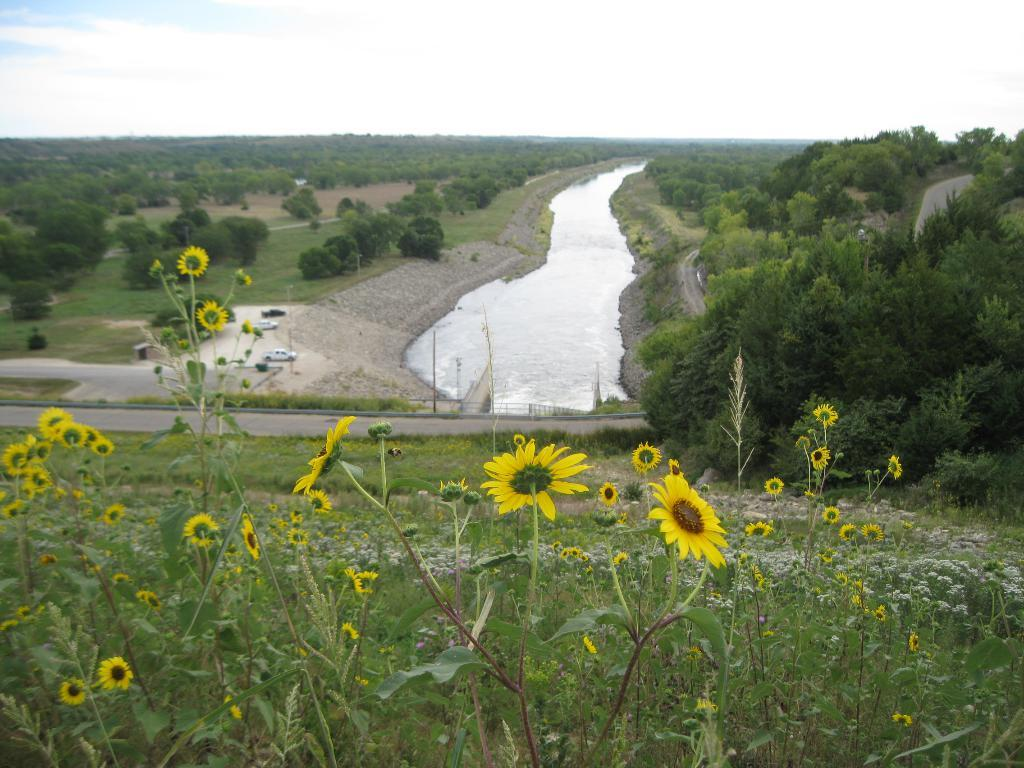What type of vegetation can be seen in the image? There is grass, trees, plants, and sunflowers in the image. Can you describe the water visible in the image? The water is visible in the image, but its specific location or characteristics are not mentioned in the facts. What are the cars doing in the middle of the image? The facts do not specify what the cars are doing in the image. What is visible at the top of the image? The sky is visible at the top of the image. What type of rice can be seen growing in the image? There is no rice visible in the image; it features grass, trees, plants, sunflowers, water, cars, and the sky. How many eyes can be seen on the sunflowers in the image? Sunflowers do not have eyes, so this question cannot be answered based on the facts provided. 